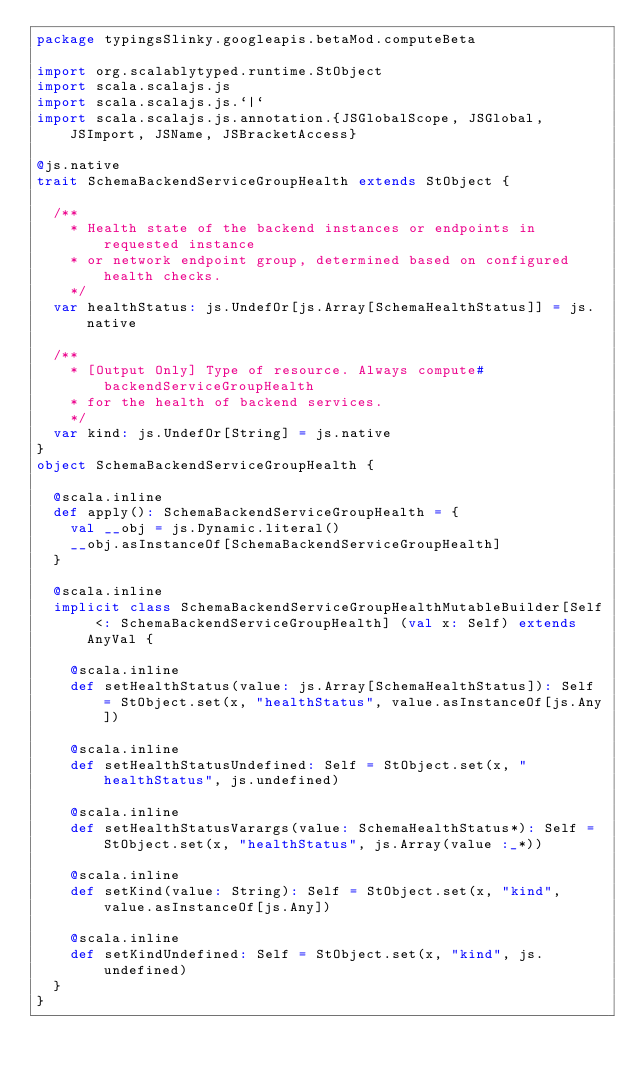Convert code to text. <code><loc_0><loc_0><loc_500><loc_500><_Scala_>package typingsSlinky.googleapis.betaMod.computeBeta

import org.scalablytyped.runtime.StObject
import scala.scalajs.js
import scala.scalajs.js.`|`
import scala.scalajs.js.annotation.{JSGlobalScope, JSGlobal, JSImport, JSName, JSBracketAccess}

@js.native
trait SchemaBackendServiceGroupHealth extends StObject {
  
  /**
    * Health state of the backend instances or endpoints in requested instance
    * or network endpoint group, determined based on configured health checks.
    */
  var healthStatus: js.UndefOr[js.Array[SchemaHealthStatus]] = js.native
  
  /**
    * [Output Only] Type of resource. Always compute#backendServiceGroupHealth
    * for the health of backend services.
    */
  var kind: js.UndefOr[String] = js.native
}
object SchemaBackendServiceGroupHealth {
  
  @scala.inline
  def apply(): SchemaBackendServiceGroupHealth = {
    val __obj = js.Dynamic.literal()
    __obj.asInstanceOf[SchemaBackendServiceGroupHealth]
  }
  
  @scala.inline
  implicit class SchemaBackendServiceGroupHealthMutableBuilder[Self <: SchemaBackendServiceGroupHealth] (val x: Self) extends AnyVal {
    
    @scala.inline
    def setHealthStatus(value: js.Array[SchemaHealthStatus]): Self = StObject.set(x, "healthStatus", value.asInstanceOf[js.Any])
    
    @scala.inline
    def setHealthStatusUndefined: Self = StObject.set(x, "healthStatus", js.undefined)
    
    @scala.inline
    def setHealthStatusVarargs(value: SchemaHealthStatus*): Self = StObject.set(x, "healthStatus", js.Array(value :_*))
    
    @scala.inline
    def setKind(value: String): Self = StObject.set(x, "kind", value.asInstanceOf[js.Any])
    
    @scala.inline
    def setKindUndefined: Self = StObject.set(x, "kind", js.undefined)
  }
}
</code> 